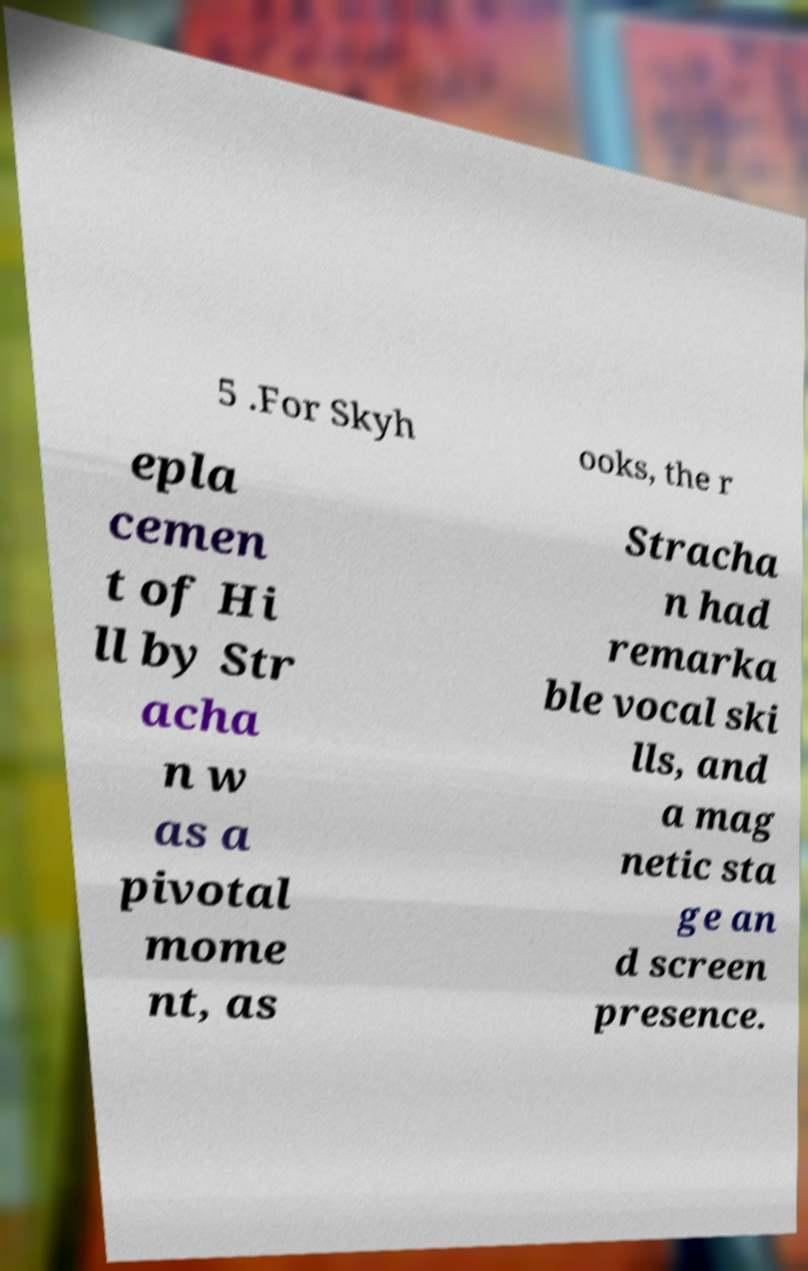Please identify and transcribe the text found in this image. 5 .For Skyh ooks, the r epla cemen t of Hi ll by Str acha n w as a pivotal mome nt, as Stracha n had remarka ble vocal ski lls, and a mag netic sta ge an d screen presence. 